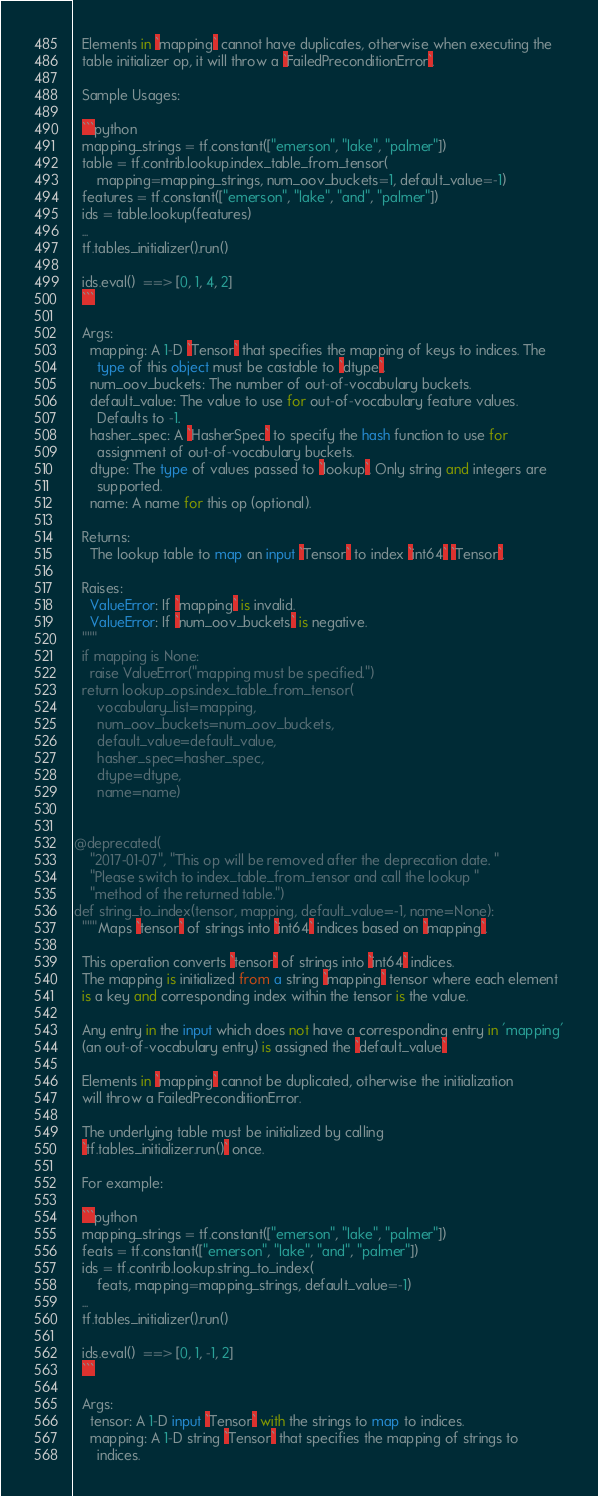Convert code to text. <code><loc_0><loc_0><loc_500><loc_500><_Python_>
  Elements in `mapping` cannot have duplicates, otherwise when executing the
  table initializer op, it will throw a `FailedPreconditionError`.

  Sample Usages:

  ```python
  mapping_strings = tf.constant(["emerson", "lake", "palmer"])
  table = tf.contrib.lookup.index_table_from_tensor(
      mapping=mapping_strings, num_oov_buckets=1, default_value=-1)
  features = tf.constant(["emerson", "lake", "and", "palmer"])
  ids = table.lookup(features)
  ...
  tf.tables_initializer().run()

  ids.eval()  ==> [0, 1, 4, 2]
  ```

  Args:
    mapping: A 1-D `Tensor` that specifies the mapping of keys to indices. The
      type of this object must be castable to `dtype`.
    num_oov_buckets: The number of out-of-vocabulary buckets.
    default_value: The value to use for out-of-vocabulary feature values.
      Defaults to -1.
    hasher_spec: A `HasherSpec` to specify the hash function to use for
      assignment of out-of-vocabulary buckets.
    dtype: The type of values passed to `lookup`. Only string and integers are
      supported.
    name: A name for this op (optional).

  Returns:
    The lookup table to map an input `Tensor` to index `int64` `Tensor`.

  Raises:
    ValueError: If `mapping` is invalid.
    ValueError: If `num_oov_buckets` is negative.
  """
  if mapping is None:
    raise ValueError("mapping must be specified.")
  return lookup_ops.index_table_from_tensor(
      vocabulary_list=mapping,
      num_oov_buckets=num_oov_buckets,
      default_value=default_value,
      hasher_spec=hasher_spec,
      dtype=dtype,
      name=name)


@deprecated(
    "2017-01-07", "This op will be removed after the deprecation date. "
    "Please switch to index_table_from_tensor and call the lookup "
    "method of the returned table.")
def string_to_index(tensor, mapping, default_value=-1, name=None):
  """Maps `tensor` of strings into `int64` indices based on `mapping`.

  This operation converts `tensor` of strings into `int64` indices.
  The mapping is initialized from a string `mapping` tensor where each element
  is a key and corresponding index within the tensor is the value.

  Any entry in the input which does not have a corresponding entry in 'mapping'
  (an out-of-vocabulary entry) is assigned the `default_value`

  Elements in `mapping` cannot be duplicated, otherwise the initialization
  will throw a FailedPreconditionError.

  The underlying table must be initialized by calling
  `tf.tables_initializer.run()` once.

  For example:

  ```python
  mapping_strings = tf.constant(["emerson", "lake", "palmer"])
  feats = tf.constant(["emerson", "lake", "and", "palmer"])
  ids = tf.contrib.lookup.string_to_index(
      feats, mapping=mapping_strings, default_value=-1)
  ...
  tf.tables_initializer().run()

  ids.eval()  ==> [0, 1, -1, 2]
  ```

  Args:
    tensor: A 1-D input `Tensor` with the strings to map to indices.
    mapping: A 1-D string `Tensor` that specifies the mapping of strings to
      indices.</code> 